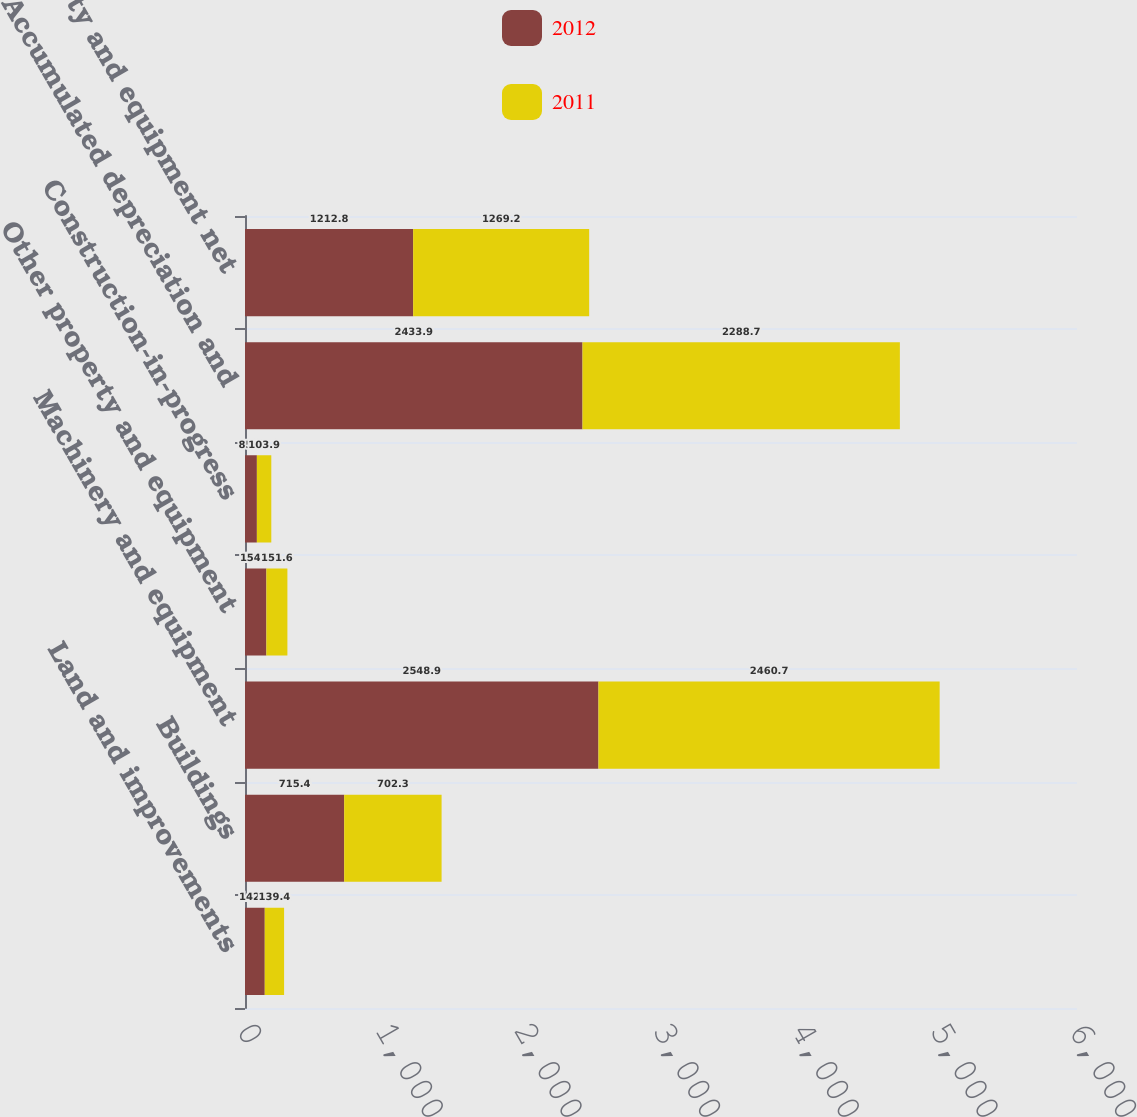<chart> <loc_0><loc_0><loc_500><loc_500><stacked_bar_chart><ecel><fcel>Land and improvements<fcel>Buildings<fcel>Machinery and equipment<fcel>Other property and equipment<fcel>Construction-in-progress<fcel>Accumulated depreciation and<fcel>Property and equipment net<nl><fcel>2012<fcel>142.5<fcel>715.4<fcel>2548.9<fcel>154.2<fcel>85.7<fcel>2433.9<fcel>1212.8<nl><fcel>2011<fcel>139.4<fcel>702.3<fcel>2460.7<fcel>151.6<fcel>103.9<fcel>2288.7<fcel>1269.2<nl></chart> 